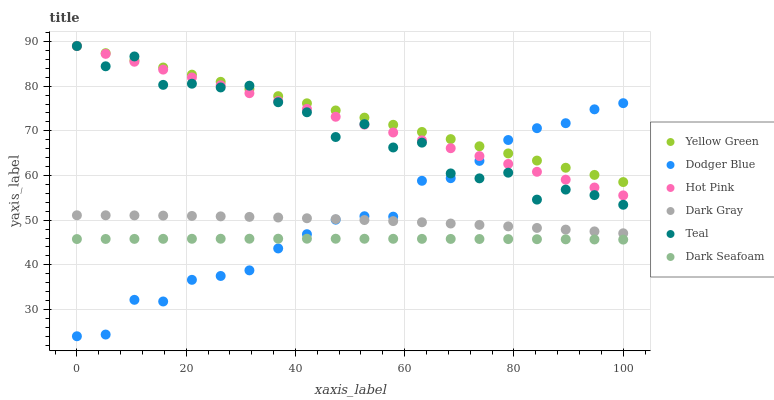Does Dark Seafoam have the minimum area under the curve?
Answer yes or no. Yes. Does Yellow Green have the maximum area under the curve?
Answer yes or no. Yes. Does Hot Pink have the minimum area under the curve?
Answer yes or no. No. Does Hot Pink have the maximum area under the curve?
Answer yes or no. No. Is Hot Pink the smoothest?
Answer yes or no. Yes. Is Teal the roughest?
Answer yes or no. Yes. Is Dark Gray the smoothest?
Answer yes or no. No. Is Dark Gray the roughest?
Answer yes or no. No. Does Dodger Blue have the lowest value?
Answer yes or no. Yes. Does Hot Pink have the lowest value?
Answer yes or no. No. Does Teal have the highest value?
Answer yes or no. Yes. Does Dark Gray have the highest value?
Answer yes or no. No. Is Dark Seafoam less than Teal?
Answer yes or no. Yes. Is Teal greater than Dark Gray?
Answer yes or no. Yes. Does Yellow Green intersect Teal?
Answer yes or no. Yes. Is Yellow Green less than Teal?
Answer yes or no. No. Is Yellow Green greater than Teal?
Answer yes or no. No. Does Dark Seafoam intersect Teal?
Answer yes or no. No. 